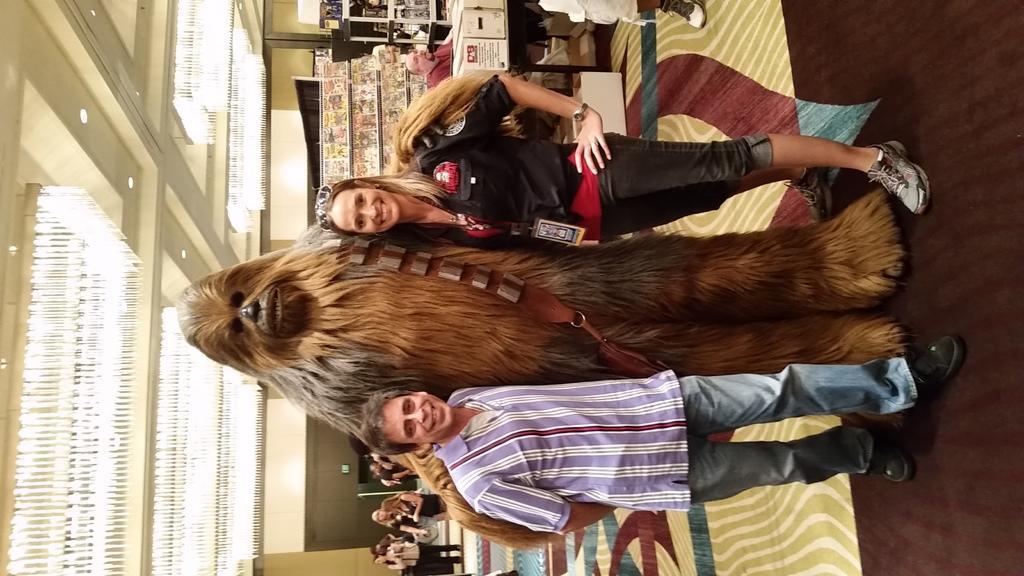Please provide a concise description of this image. In this picture we can see there are two people standing and in between the people there is a person in the fancy dress. Behind the people there are groups of people standing and a person is sitting and at the top there are ceiling lights and behind the people there is a wall and other things. 